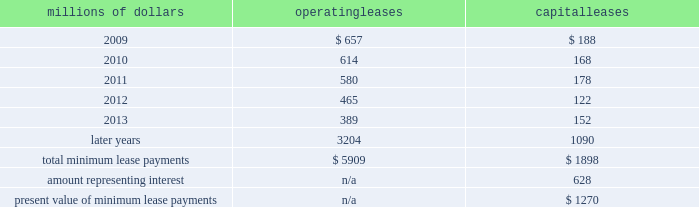14 .
Leases we lease certain locomotives , freight cars , and other property .
The consolidated statement of financial position as of december 31 , 2008 and 2007 included $ 2024 million , net of $ 869 million of amortization , and $ 2062 million , net of $ 887 million of amortization , respectively , for properties held under capital leases .
A charge to income resulting from the amortization for assets held under capital leases is included within depreciation expense in our consolidated statements of income .
Future minimum lease payments for operating and capital leases with initial or remaining non-cancelable lease terms in excess of one year as of december 31 , 2008 were as follows : millions of dollars operating leases capital leases .
The majority of capital lease payments relate to locomotives .
Rent expense for operating leases with terms exceeding one month was $ 747 million in 2008 , $ 810 million in 2007 , and $ 798 million in 2006 .
When cash rental payments are not made on a straight-line basis , we recognize variable rental expense on a straight-line basis over the lease term .
Contingent rentals and sub-rentals are not significant .
15 .
Commitments and contingencies asserted and unasserted claims 2013 various claims and lawsuits are pending against us and certain of our subsidiaries .
We cannot fully determine the effect of all asserted and unasserted claims on our consolidated results of operations , financial condition , or liquidity ; however , to the extent possible , where asserted and unasserted claims are considered probable and where such claims can be reasonably estimated , we have recorded a liability .
We do not expect that any known lawsuits , claims , environmental costs , commitments , contingent liabilities , or guarantees will have a material adverse effect on our consolidated results of operations , financial condition , or liquidity after taking into account liabilities and insurance recoveries previously recorded for these matters .
Personal injury 2013 the cost of personal injuries to employees and others related to our activities is charged to expense based on estimates of the ultimate cost and number of incidents each year .
We use third-party actuaries to assist us in measuring the expense and liability , including unasserted claims .
The federal employers 2019 liability act ( fela ) governs compensation for work-related accidents .
Under fela , damages are assessed based on a finding of fault through litigation or out-of-court settlements .
We offer a comprehensive variety of services and rehabilitation programs for employees who are injured at our personal injury liability is discounted to present value using applicable u.s .
Treasury rates .
Approximately 88% ( 88 % ) of the recorded liability related to asserted claims , and approximately 12% ( 12 % ) related to unasserted claims at december 31 , 2008 .
Because of the uncertainty surrounding the ultimate outcome of personal injury claims , it is reasonably possible that future costs to settle these claims may range from .
As of december 312008 what was the percent of the future minimum lease payments for operating and capital leases that was due in 2009? 
Computations: ((657 + 188) / (5909 + 1898))
Answer: 0.10824. 